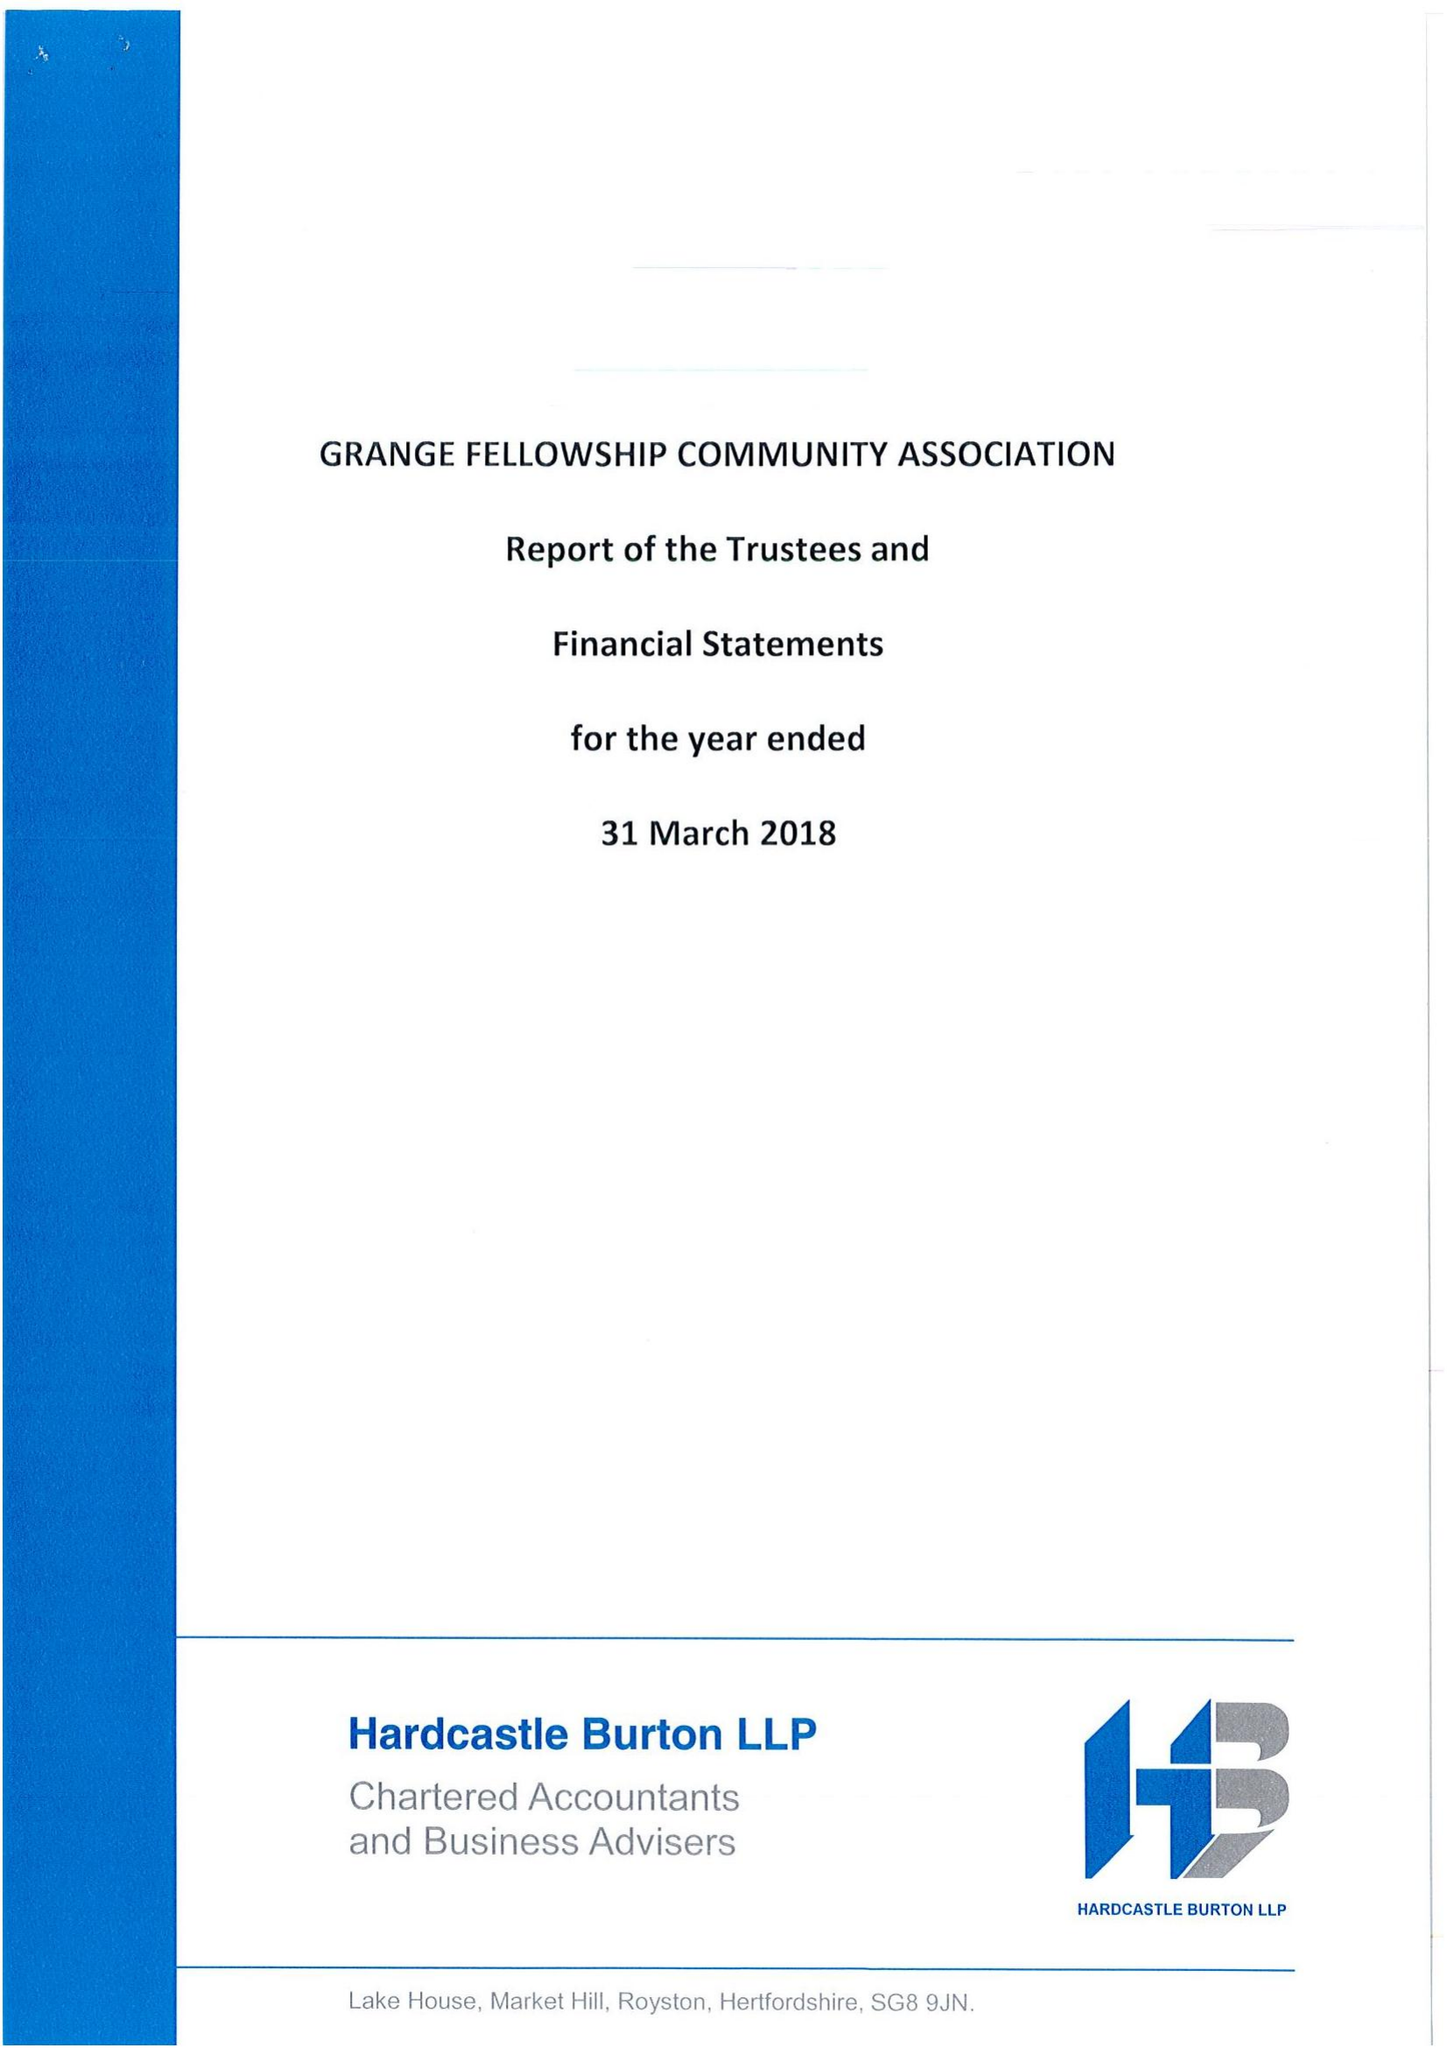What is the value for the address__postcode?
Answer the question using a single word or phrase. SG6 4NG 